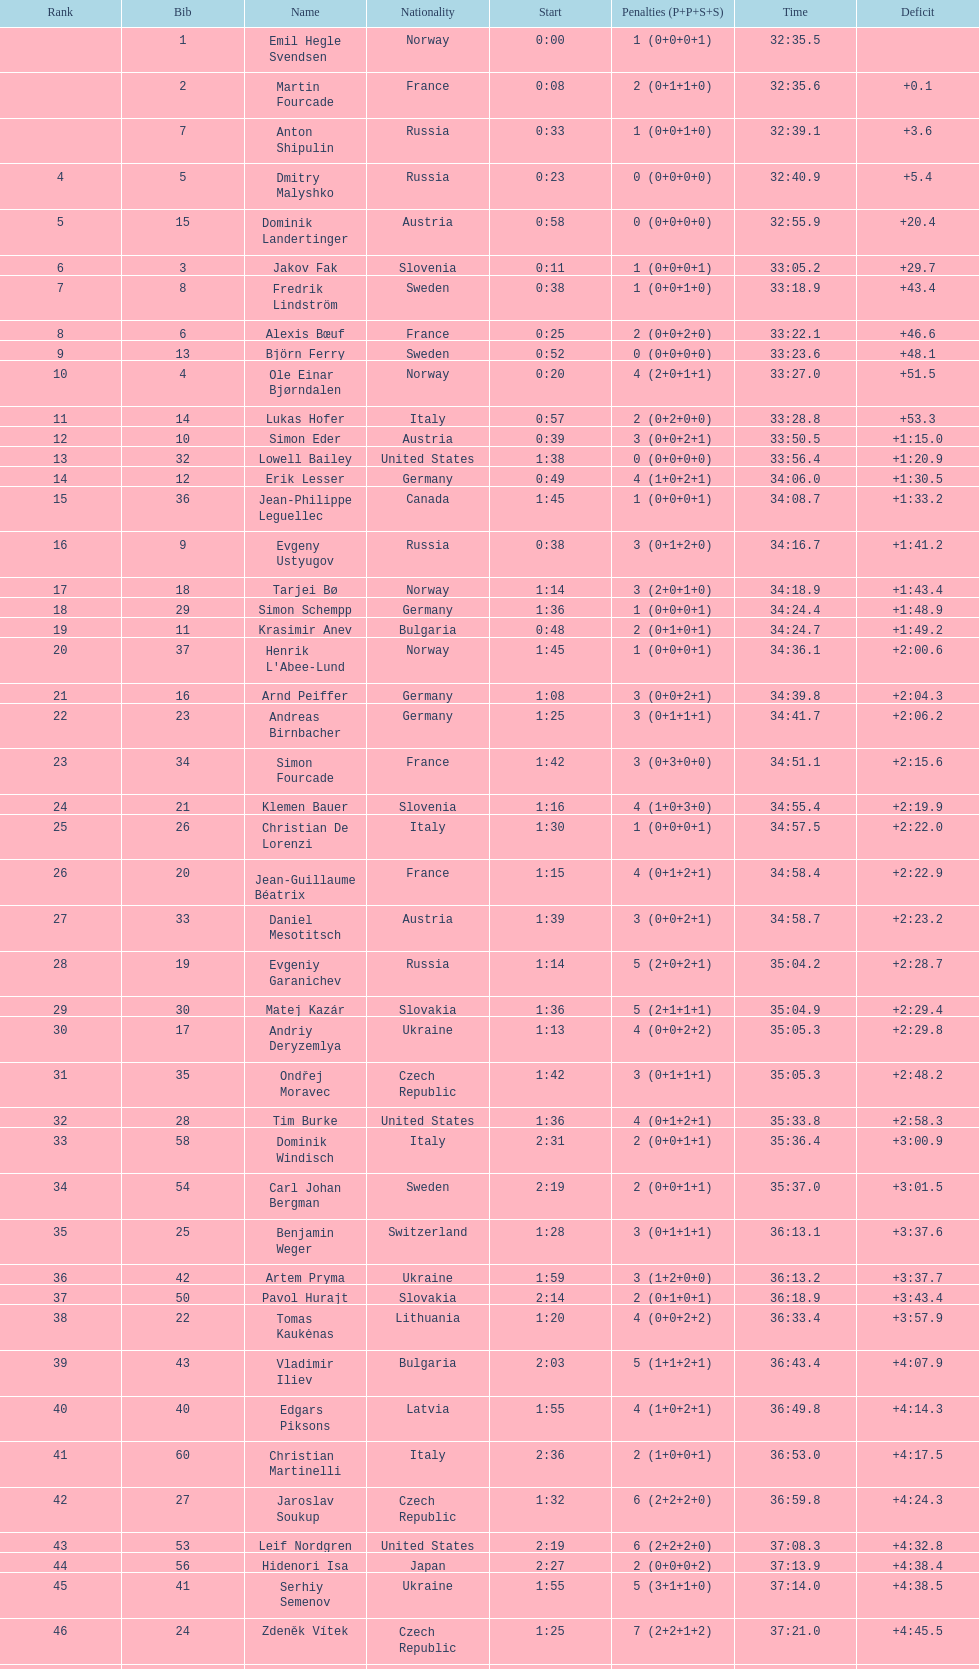How many finished in not less than 35:00? 30. 